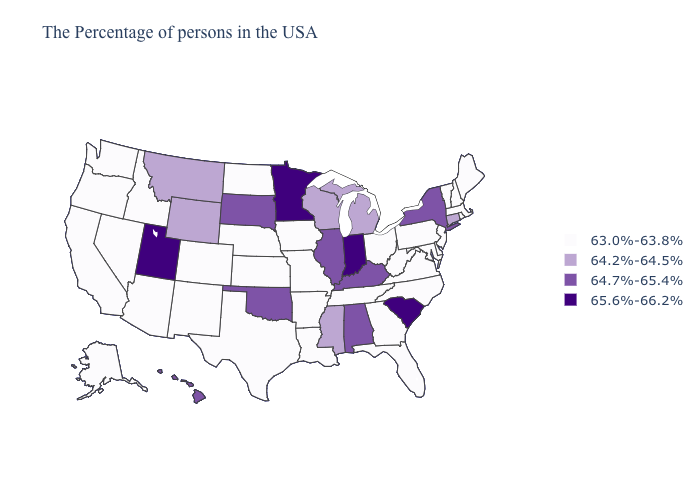How many symbols are there in the legend?
Short answer required. 4. Name the states that have a value in the range 64.2%-64.5%?
Short answer required. Connecticut, Michigan, Wisconsin, Mississippi, Wyoming, Montana. Among the states that border Iowa , which have the lowest value?
Concise answer only. Missouri, Nebraska. Does Wyoming have the highest value in the USA?
Quick response, please. No. Name the states that have a value in the range 65.6%-66.2%?
Quick response, please. South Carolina, Indiana, Minnesota, Utah. Name the states that have a value in the range 64.2%-64.5%?
Concise answer only. Connecticut, Michigan, Wisconsin, Mississippi, Wyoming, Montana. Name the states that have a value in the range 64.7%-65.4%?
Be succinct. New York, Kentucky, Alabama, Illinois, Oklahoma, South Dakota, Hawaii. Name the states that have a value in the range 64.7%-65.4%?
Give a very brief answer. New York, Kentucky, Alabama, Illinois, Oklahoma, South Dakota, Hawaii. Among the states that border Arizona , does Nevada have the lowest value?
Quick response, please. Yes. What is the highest value in the Northeast ?
Concise answer only. 64.7%-65.4%. Does Pennsylvania have the same value as Massachusetts?
Be succinct. Yes. What is the lowest value in the USA?
Concise answer only. 63.0%-63.8%. Name the states that have a value in the range 64.7%-65.4%?
Answer briefly. New York, Kentucky, Alabama, Illinois, Oklahoma, South Dakota, Hawaii. What is the value of Michigan?
Quick response, please. 64.2%-64.5%. Name the states that have a value in the range 64.2%-64.5%?
Short answer required. Connecticut, Michigan, Wisconsin, Mississippi, Wyoming, Montana. 